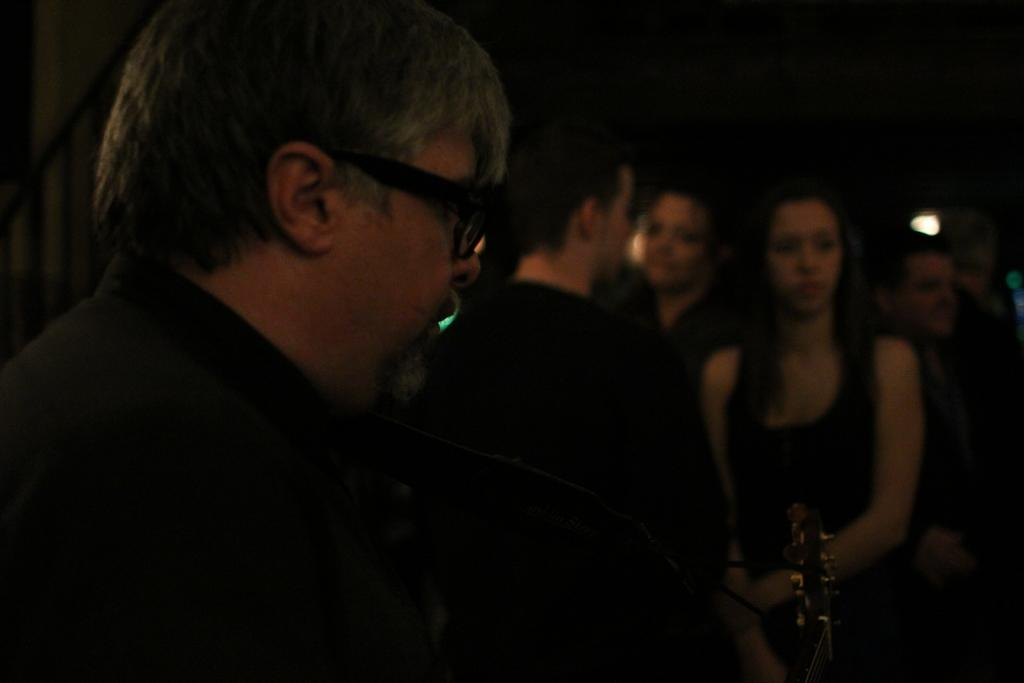How many people are in the image? There are people in the image, but the exact number is not specified. Can you describe the lighting in the image? There is light visible in the image. What is the appearance of the background in the image? The background of the image appears to be dark. What is the "thing" in the image? The facts only mention an unspecified "thing" in the image, so we cannot provide more details about it. How many bikes are parked next to the people in the image? There is no mention of bikes in the image, so we cannot answer this question. What type of badge is the person wearing in the image? There is no mention of a badge or any specific clothing in the image, so we cannot answer this question. 